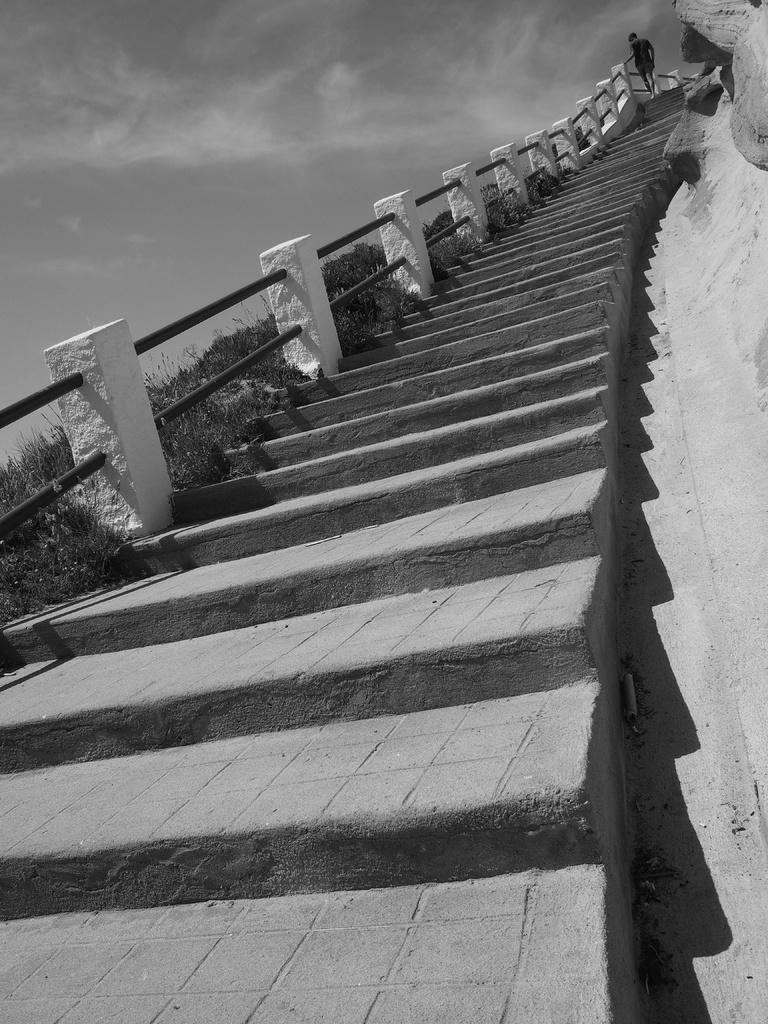Could you give a brief overview of what you see in this image? In this image we can see a person walking on the steps and to the side of it we can see some plants. We can also see the sky. 